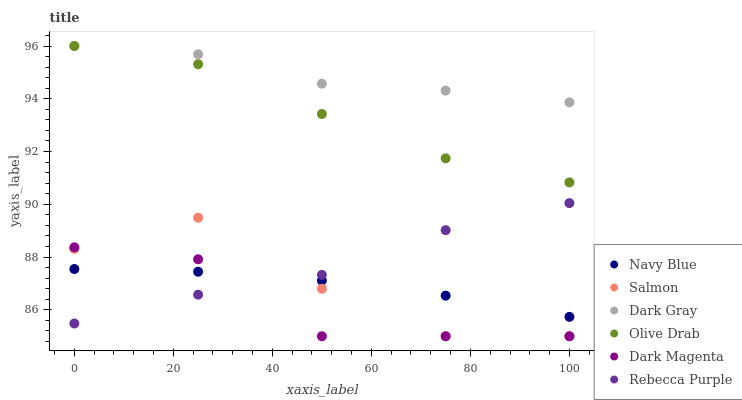Does Dark Magenta have the minimum area under the curve?
Answer yes or no. Yes. Does Dark Gray have the maximum area under the curve?
Answer yes or no. Yes. Does Navy Blue have the minimum area under the curve?
Answer yes or no. No. Does Navy Blue have the maximum area under the curve?
Answer yes or no. No. Is Navy Blue the smoothest?
Answer yes or no. Yes. Is Salmon the roughest?
Answer yes or no. Yes. Is Salmon the smoothest?
Answer yes or no. No. Is Navy Blue the roughest?
Answer yes or no. No. Does Dark Magenta have the lowest value?
Answer yes or no. Yes. Does Navy Blue have the lowest value?
Answer yes or no. No. Does Olive Drab have the highest value?
Answer yes or no. Yes. Does Salmon have the highest value?
Answer yes or no. No. Is Salmon less than Dark Gray?
Answer yes or no. Yes. Is Olive Drab greater than Rebecca Purple?
Answer yes or no. Yes. Does Navy Blue intersect Dark Magenta?
Answer yes or no. Yes. Is Navy Blue less than Dark Magenta?
Answer yes or no. No. Is Navy Blue greater than Dark Magenta?
Answer yes or no. No. Does Salmon intersect Dark Gray?
Answer yes or no. No. 